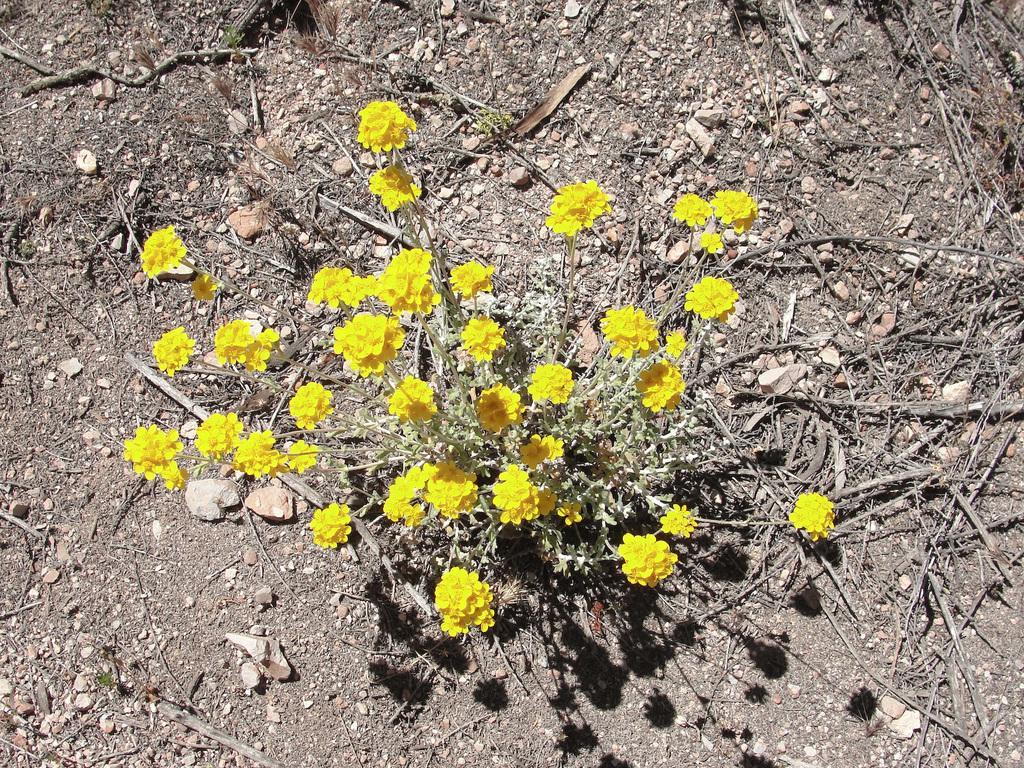Please provide a concise description of this image. In this image we can see yellow flower plant, branches and rocks.  